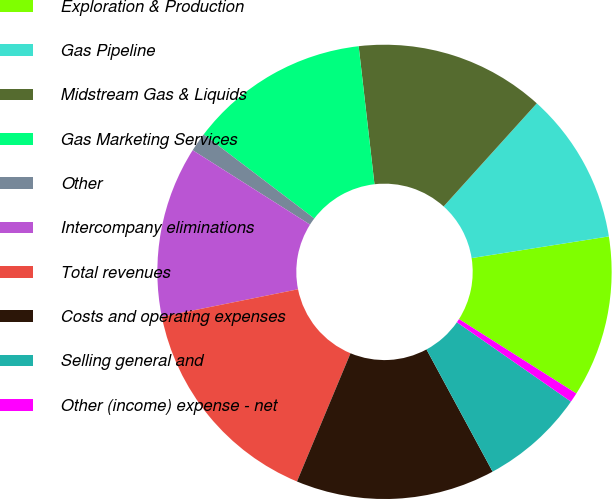<chart> <loc_0><loc_0><loc_500><loc_500><pie_chart><fcel>Exploration & Production<fcel>Gas Pipeline<fcel>Midstream Gas & Liquids<fcel>Gas Marketing Services<fcel>Other<fcel>Intercompany eliminations<fcel>Total revenues<fcel>Costs and operating expenses<fcel>Selling general and<fcel>Other (income) expense - net<nl><fcel>11.49%<fcel>10.81%<fcel>13.51%<fcel>12.84%<fcel>1.35%<fcel>12.16%<fcel>15.54%<fcel>14.19%<fcel>7.43%<fcel>0.68%<nl></chart> 